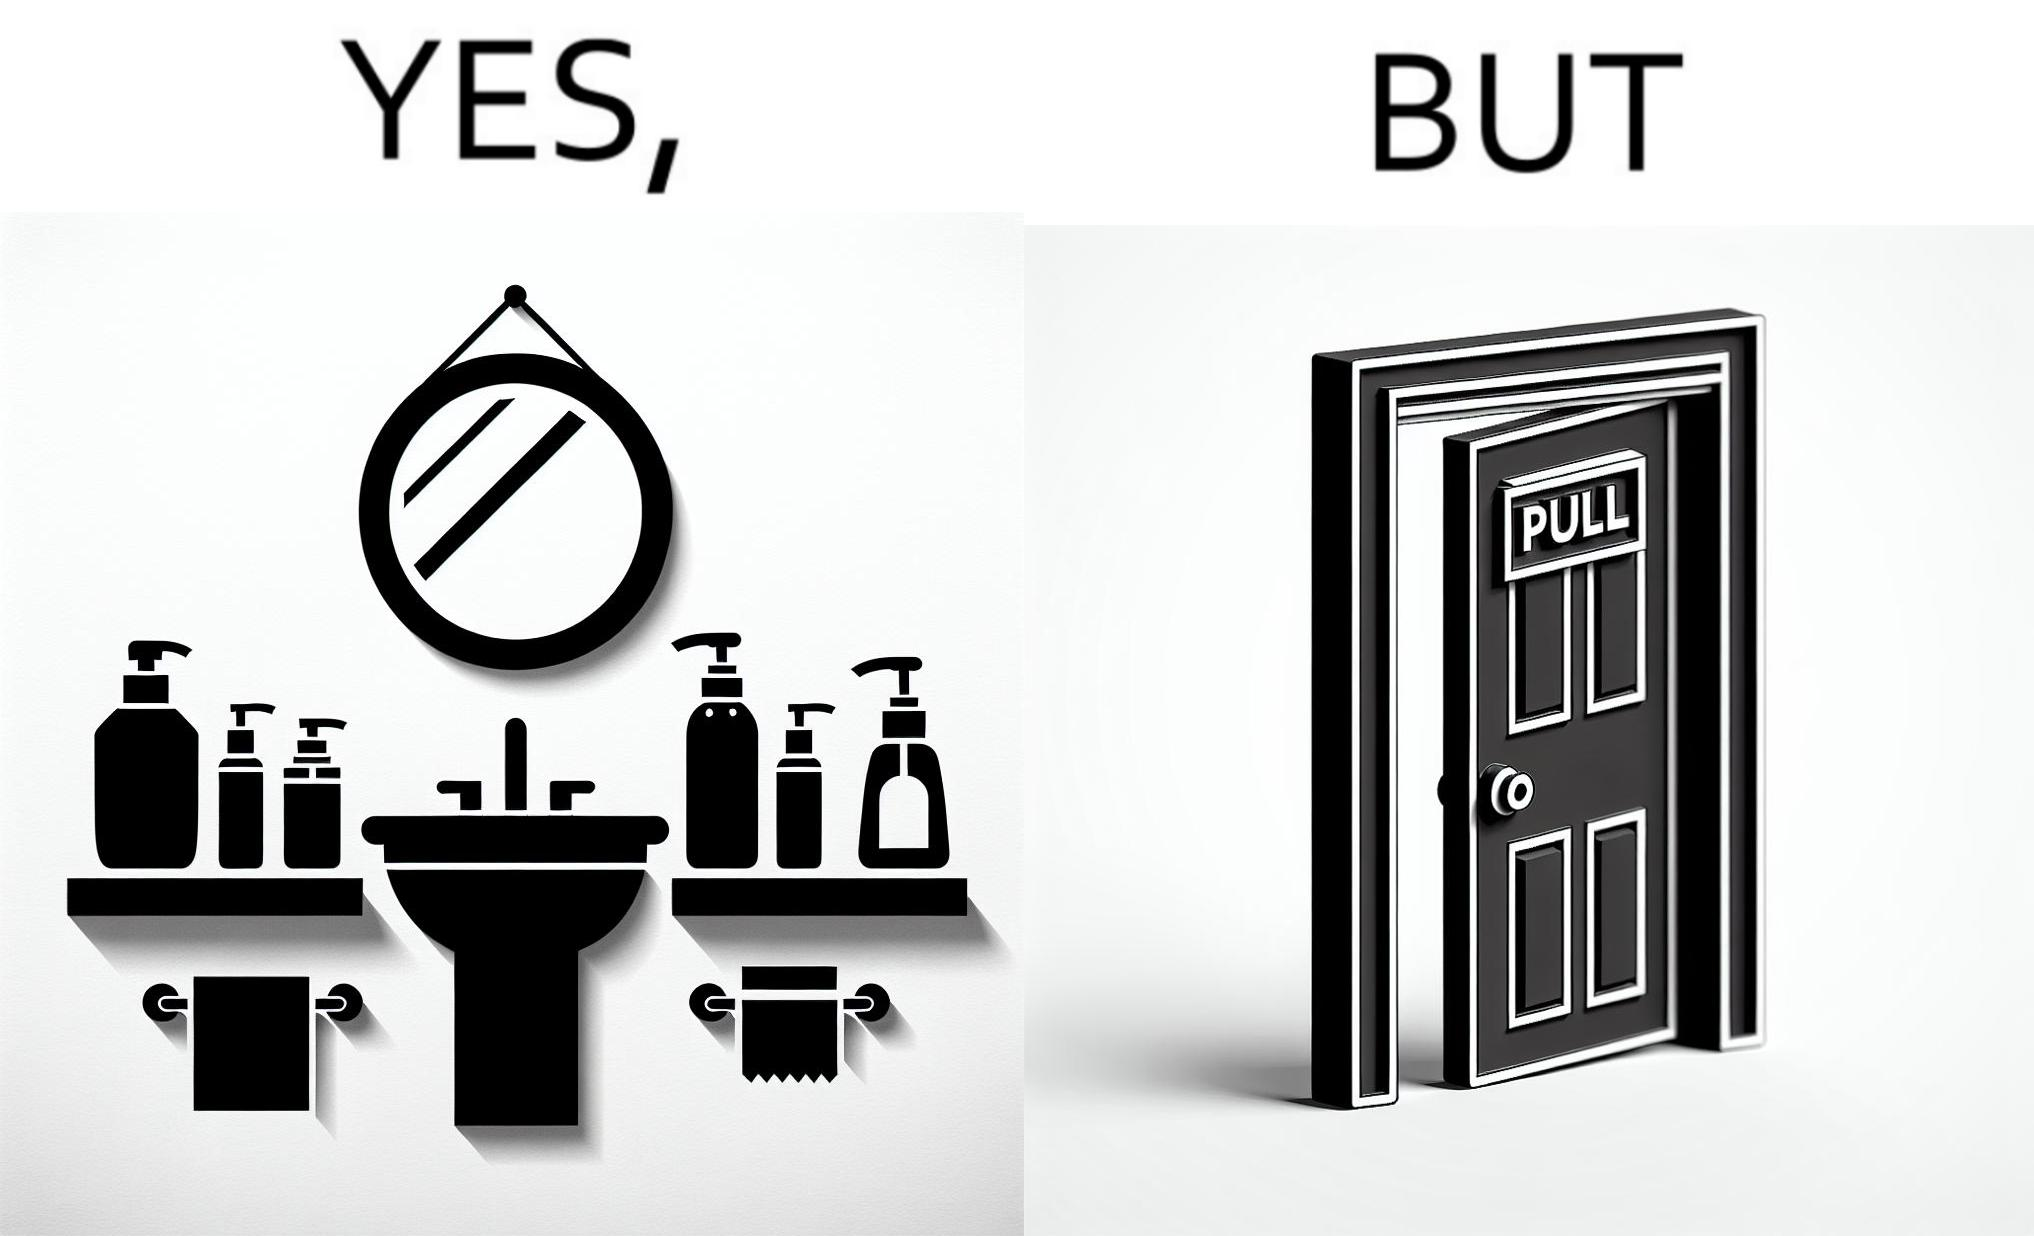Is this a satirical image? Yes, this image is satirical. 